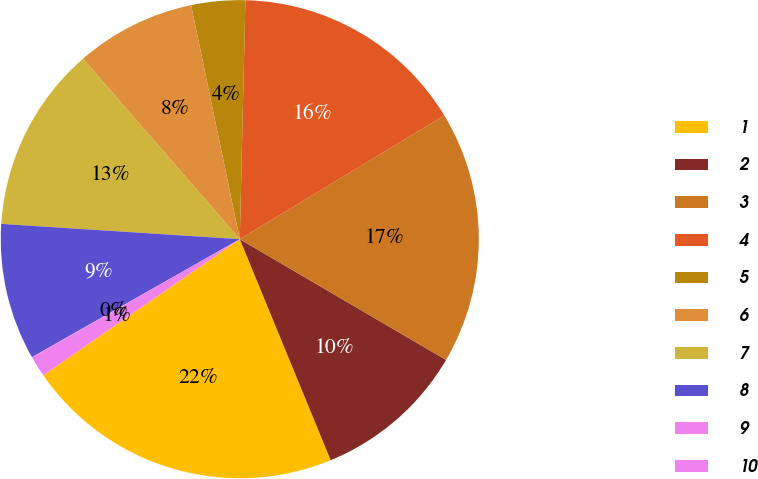Convert chart. <chart><loc_0><loc_0><loc_500><loc_500><pie_chart><fcel>1<fcel>2<fcel>3<fcel>4<fcel>5<fcel>6<fcel>7<fcel>8<fcel>9<fcel>10<nl><fcel>21.57%<fcel>10.36%<fcel>17.09%<fcel>15.97%<fcel>3.64%<fcel>8.12%<fcel>12.6%<fcel>9.24%<fcel>0.03%<fcel>1.39%<nl></chart> 